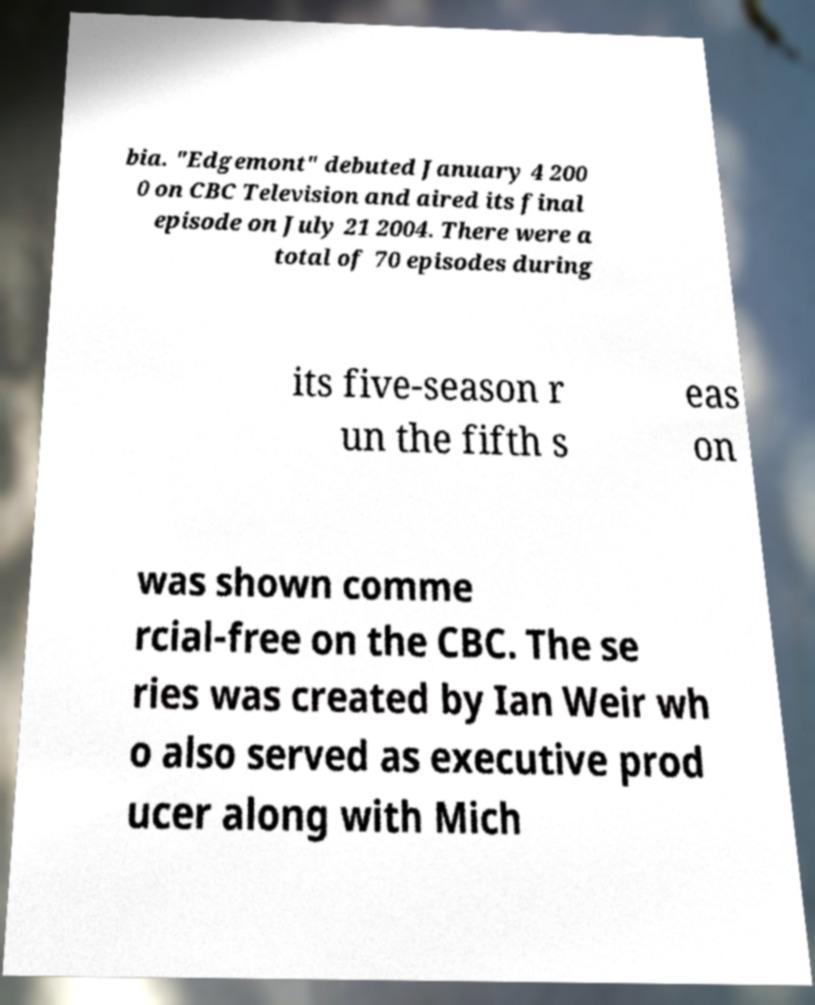I need the written content from this picture converted into text. Can you do that? bia. "Edgemont" debuted January 4 200 0 on CBC Television and aired its final episode on July 21 2004. There were a total of 70 episodes during its five-season r un the fifth s eas on was shown comme rcial-free on the CBC. The se ries was created by Ian Weir wh o also served as executive prod ucer along with Mich 